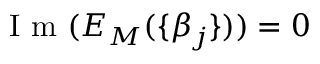Convert formula to latex. <formula><loc_0><loc_0><loc_500><loc_500>I m ( E _ { M } ( \{ \beta _ { j } \} ) ) = 0</formula> 